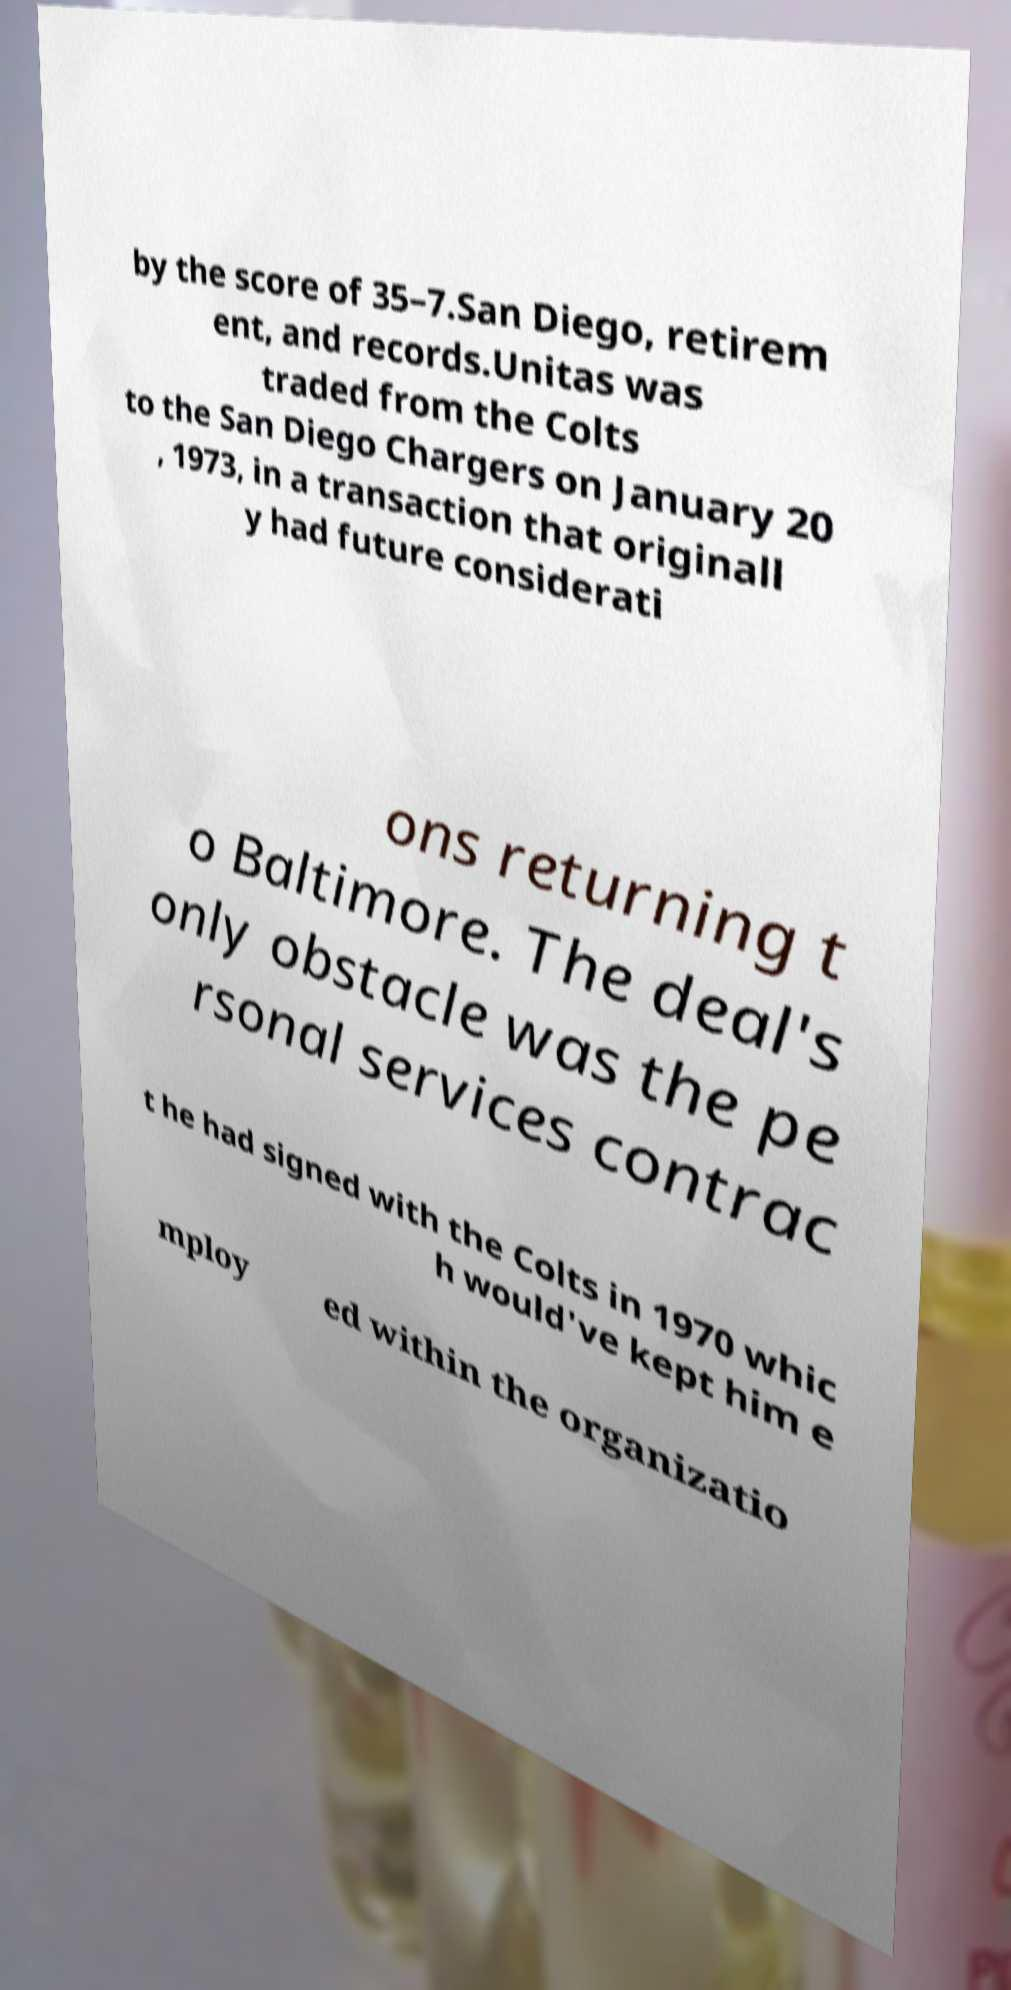I need the written content from this picture converted into text. Can you do that? by the score of 35–7.San Diego, retirem ent, and records.Unitas was traded from the Colts to the San Diego Chargers on January 20 , 1973, in a transaction that originall y had future considerati ons returning t o Baltimore. The deal's only obstacle was the pe rsonal services contrac t he had signed with the Colts in 1970 whic h would've kept him e mploy ed within the organizatio 